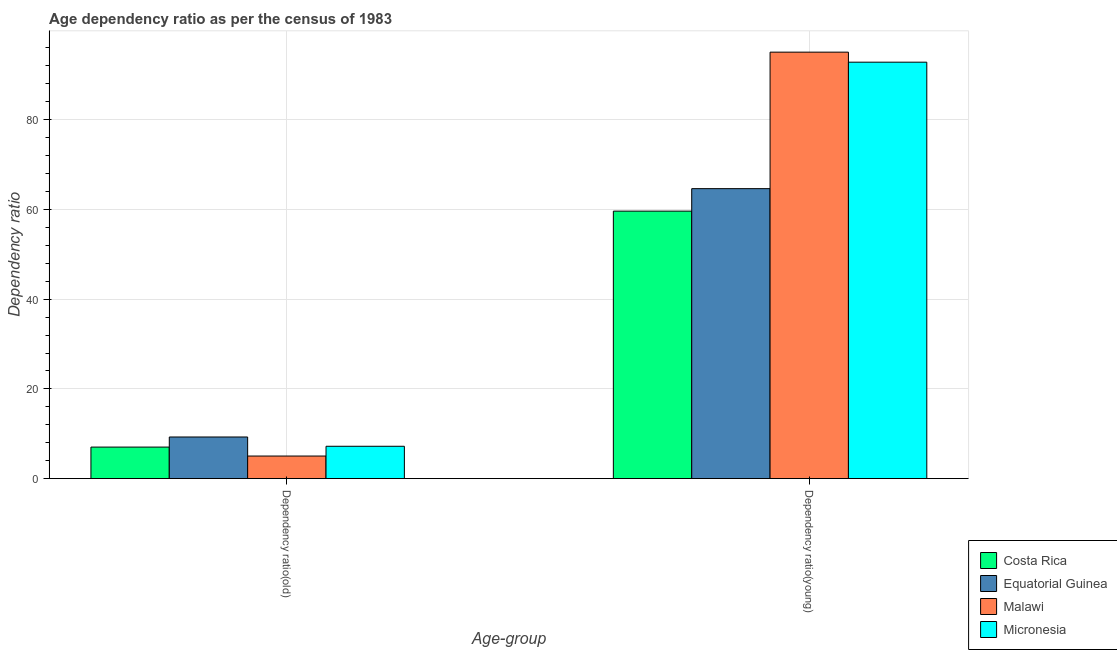How many different coloured bars are there?
Make the answer very short. 4. How many groups of bars are there?
Offer a very short reply. 2. Are the number of bars per tick equal to the number of legend labels?
Make the answer very short. Yes. What is the label of the 1st group of bars from the left?
Keep it short and to the point. Dependency ratio(old). What is the age dependency ratio(old) in Costa Rica?
Give a very brief answer. 7.03. Across all countries, what is the maximum age dependency ratio(old)?
Your response must be concise. 9.28. Across all countries, what is the minimum age dependency ratio(old)?
Your answer should be compact. 5.03. In which country was the age dependency ratio(old) maximum?
Offer a very short reply. Equatorial Guinea. What is the total age dependency ratio(old) in the graph?
Provide a short and direct response. 28.55. What is the difference between the age dependency ratio(old) in Micronesia and that in Equatorial Guinea?
Your response must be concise. -2.07. What is the difference between the age dependency ratio(young) in Micronesia and the age dependency ratio(old) in Malawi?
Your answer should be very brief. 87.8. What is the average age dependency ratio(young) per country?
Your answer should be very brief. 78.04. What is the difference between the age dependency ratio(young) and age dependency ratio(old) in Malawi?
Your answer should be very brief. 90.03. In how many countries, is the age dependency ratio(old) greater than 44 ?
Make the answer very short. 0. What is the ratio of the age dependency ratio(old) in Micronesia to that in Costa Rica?
Give a very brief answer. 1.03. What does the 1st bar from the left in Dependency ratio(old) represents?
Make the answer very short. Costa Rica. What does the 4th bar from the right in Dependency ratio(young) represents?
Make the answer very short. Costa Rica. How many bars are there?
Ensure brevity in your answer.  8. Are all the bars in the graph horizontal?
Ensure brevity in your answer.  No. What is the difference between two consecutive major ticks on the Y-axis?
Your answer should be very brief. 20. Are the values on the major ticks of Y-axis written in scientific E-notation?
Your response must be concise. No. Does the graph contain any zero values?
Offer a terse response. No. Does the graph contain grids?
Ensure brevity in your answer.  Yes. How many legend labels are there?
Offer a terse response. 4. How are the legend labels stacked?
Offer a terse response. Vertical. What is the title of the graph?
Your answer should be very brief. Age dependency ratio as per the census of 1983. What is the label or title of the X-axis?
Your answer should be very brief. Age-group. What is the label or title of the Y-axis?
Your response must be concise. Dependency ratio. What is the Dependency ratio in Costa Rica in Dependency ratio(old)?
Give a very brief answer. 7.03. What is the Dependency ratio of Equatorial Guinea in Dependency ratio(old)?
Your response must be concise. 9.28. What is the Dependency ratio of Malawi in Dependency ratio(old)?
Your answer should be compact. 5.03. What is the Dependency ratio in Micronesia in Dependency ratio(old)?
Your answer should be compact. 7.21. What is the Dependency ratio in Costa Rica in Dependency ratio(young)?
Offer a terse response. 59.62. What is the Dependency ratio of Equatorial Guinea in Dependency ratio(young)?
Offer a terse response. 64.64. What is the Dependency ratio of Malawi in Dependency ratio(young)?
Provide a short and direct response. 95.07. What is the Dependency ratio of Micronesia in Dependency ratio(young)?
Give a very brief answer. 92.83. Across all Age-group, what is the maximum Dependency ratio of Costa Rica?
Your answer should be compact. 59.62. Across all Age-group, what is the maximum Dependency ratio of Equatorial Guinea?
Give a very brief answer. 64.64. Across all Age-group, what is the maximum Dependency ratio of Malawi?
Offer a very short reply. 95.07. Across all Age-group, what is the maximum Dependency ratio of Micronesia?
Make the answer very short. 92.83. Across all Age-group, what is the minimum Dependency ratio of Costa Rica?
Provide a short and direct response. 7.03. Across all Age-group, what is the minimum Dependency ratio in Equatorial Guinea?
Your answer should be very brief. 9.28. Across all Age-group, what is the minimum Dependency ratio in Malawi?
Provide a succinct answer. 5.03. Across all Age-group, what is the minimum Dependency ratio in Micronesia?
Provide a short and direct response. 7.21. What is the total Dependency ratio of Costa Rica in the graph?
Keep it short and to the point. 66.65. What is the total Dependency ratio in Equatorial Guinea in the graph?
Make the answer very short. 73.92. What is the total Dependency ratio of Malawi in the graph?
Keep it short and to the point. 100.1. What is the total Dependency ratio in Micronesia in the graph?
Provide a succinct answer. 100.04. What is the difference between the Dependency ratio in Costa Rica in Dependency ratio(old) and that in Dependency ratio(young)?
Provide a succinct answer. -52.6. What is the difference between the Dependency ratio of Equatorial Guinea in Dependency ratio(old) and that in Dependency ratio(young)?
Keep it short and to the point. -55.36. What is the difference between the Dependency ratio in Malawi in Dependency ratio(old) and that in Dependency ratio(young)?
Ensure brevity in your answer.  -90.03. What is the difference between the Dependency ratio of Micronesia in Dependency ratio(old) and that in Dependency ratio(young)?
Make the answer very short. -85.62. What is the difference between the Dependency ratio of Costa Rica in Dependency ratio(old) and the Dependency ratio of Equatorial Guinea in Dependency ratio(young)?
Offer a very short reply. -57.61. What is the difference between the Dependency ratio in Costa Rica in Dependency ratio(old) and the Dependency ratio in Malawi in Dependency ratio(young)?
Your answer should be very brief. -88.04. What is the difference between the Dependency ratio of Costa Rica in Dependency ratio(old) and the Dependency ratio of Micronesia in Dependency ratio(young)?
Offer a terse response. -85.8. What is the difference between the Dependency ratio of Equatorial Guinea in Dependency ratio(old) and the Dependency ratio of Malawi in Dependency ratio(young)?
Ensure brevity in your answer.  -85.79. What is the difference between the Dependency ratio of Equatorial Guinea in Dependency ratio(old) and the Dependency ratio of Micronesia in Dependency ratio(young)?
Offer a terse response. -83.55. What is the difference between the Dependency ratio of Malawi in Dependency ratio(old) and the Dependency ratio of Micronesia in Dependency ratio(young)?
Offer a very short reply. -87.8. What is the average Dependency ratio of Costa Rica per Age-group?
Your response must be concise. 33.33. What is the average Dependency ratio in Equatorial Guinea per Age-group?
Your answer should be very brief. 36.96. What is the average Dependency ratio of Malawi per Age-group?
Offer a very short reply. 50.05. What is the average Dependency ratio in Micronesia per Age-group?
Keep it short and to the point. 50.02. What is the difference between the Dependency ratio of Costa Rica and Dependency ratio of Equatorial Guinea in Dependency ratio(old)?
Offer a very short reply. -2.25. What is the difference between the Dependency ratio of Costa Rica and Dependency ratio of Malawi in Dependency ratio(old)?
Offer a terse response. 2. What is the difference between the Dependency ratio of Costa Rica and Dependency ratio of Micronesia in Dependency ratio(old)?
Your answer should be compact. -0.18. What is the difference between the Dependency ratio in Equatorial Guinea and Dependency ratio in Malawi in Dependency ratio(old)?
Make the answer very short. 4.25. What is the difference between the Dependency ratio of Equatorial Guinea and Dependency ratio of Micronesia in Dependency ratio(old)?
Keep it short and to the point. 2.07. What is the difference between the Dependency ratio in Malawi and Dependency ratio in Micronesia in Dependency ratio(old)?
Provide a succinct answer. -2.18. What is the difference between the Dependency ratio of Costa Rica and Dependency ratio of Equatorial Guinea in Dependency ratio(young)?
Make the answer very short. -5.02. What is the difference between the Dependency ratio in Costa Rica and Dependency ratio in Malawi in Dependency ratio(young)?
Give a very brief answer. -35.44. What is the difference between the Dependency ratio in Costa Rica and Dependency ratio in Micronesia in Dependency ratio(young)?
Provide a succinct answer. -33.21. What is the difference between the Dependency ratio in Equatorial Guinea and Dependency ratio in Malawi in Dependency ratio(young)?
Give a very brief answer. -30.43. What is the difference between the Dependency ratio of Equatorial Guinea and Dependency ratio of Micronesia in Dependency ratio(young)?
Provide a succinct answer. -28.19. What is the difference between the Dependency ratio of Malawi and Dependency ratio of Micronesia in Dependency ratio(young)?
Keep it short and to the point. 2.24. What is the ratio of the Dependency ratio of Costa Rica in Dependency ratio(old) to that in Dependency ratio(young)?
Your answer should be compact. 0.12. What is the ratio of the Dependency ratio of Equatorial Guinea in Dependency ratio(old) to that in Dependency ratio(young)?
Your response must be concise. 0.14. What is the ratio of the Dependency ratio in Malawi in Dependency ratio(old) to that in Dependency ratio(young)?
Ensure brevity in your answer.  0.05. What is the ratio of the Dependency ratio of Micronesia in Dependency ratio(old) to that in Dependency ratio(young)?
Give a very brief answer. 0.08. What is the difference between the highest and the second highest Dependency ratio in Costa Rica?
Make the answer very short. 52.6. What is the difference between the highest and the second highest Dependency ratio of Equatorial Guinea?
Give a very brief answer. 55.36. What is the difference between the highest and the second highest Dependency ratio in Malawi?
Ensure brevity in your answer.  90.03. What is the difference between the highest and the second highest Dependency ratio in Micronesia?
Provide a short and direct response. 85.62. What is the difference between the highest and the lowest Dependency ratio in Costa Rica?
Provide a short and direct response. 52.6. What is the difference between the highest and the lowest Dependency ratio of Equatorial Guinea?
Provide a succinct answer. 55.36. What is the difference between the highest and the lowest Dependency ratio of Malawi?
Provide a short and direct response. 90.03. What is the difference between the highest and the lowest Dependency ratio in Micronesia?
Your answer should be compact. 85.62. 